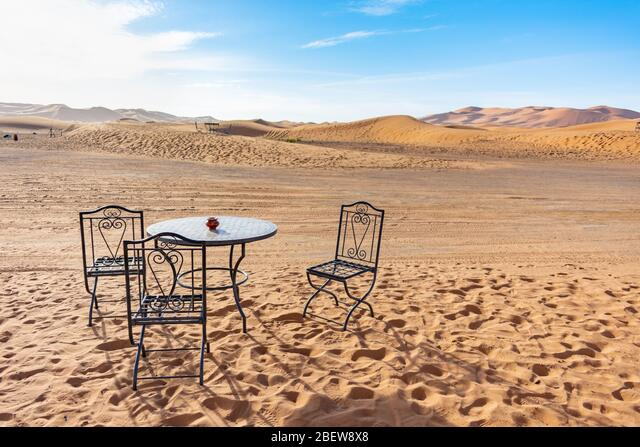What might be the purpose of this furniture arrangement in the desert? This could be part of an outdoor event, an artistic installation, or simply a whimsical touch by someone enjoying the desert panorama. Its purpose is open to interpretation, creating an intriguing visual narrative. 